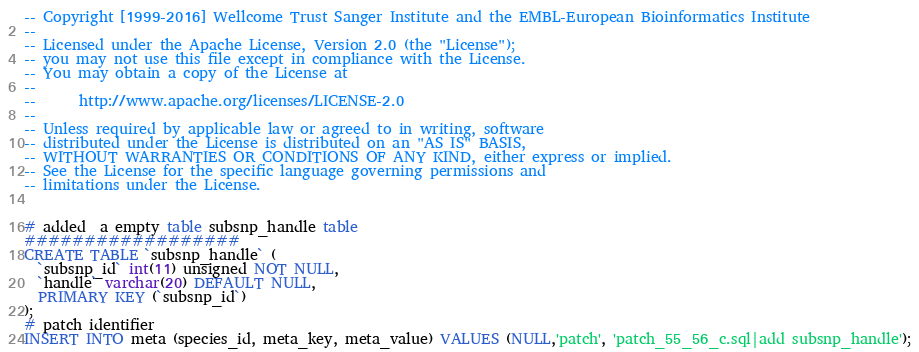Convert code to text. <code><loc_0><loc_0><loc_500><loc_500><_SQL_>-- Copyright [1999-2016] Wellcome Trust Sanger Institute and the EMBL-European Bioinformatics Institute
-- 
-- Licensed under the Apache License, Version 2.0 (the "License");
-- you may not use this file except in compliance with the License.
-- You may obtain a copy of the License at
-- 
--      http://www.apache.org/licenses/LICENSE-2.0
-- 
-- Unless required by applicable law or agreed to in writing, software
-- distributed under the License is distributed on an "AS IS" BASIS,
-- WITHOUT WARRANTIES OR CONDITIONS OF ANY KIND, either express or implied.
-- See the License for the specific language governing permissions and
-- limitations under the License.


# added  a empty table subsnp_handle table
##################
CREATE TABLE `subsnp_handle` (
  `subsnp_id` int(11) unsigned NOT NULL,
  `handle` varchar(20) DEFAULT NULL,
  PRIMARY KEY (`subsnp_id`)
);
# patch identifier
INSERT INTO meta (species_id, meta_key, meta_value) VALUES (NULL,'patch', 'patch_55_56_c.sql|add subsnp_handle');
</code> 